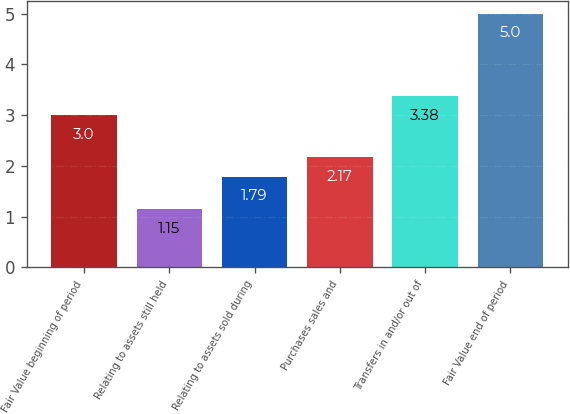Convert chart. <chart><loc_0><loc_0><loc_500><loc_500><bar_chart><fcel>Fair Value beginning of period<fcel>Relating to assets still held<fcel>Relating to assets sold during<fcel>Purchases sales and<fcel>Transfers in and/or out of<fcel>Fair Value end of period<nl><fcel>3<fcel>1.15<fcel>1.79<fcel>2.17<fcel>3.38<fcel>5<nl></chart> 